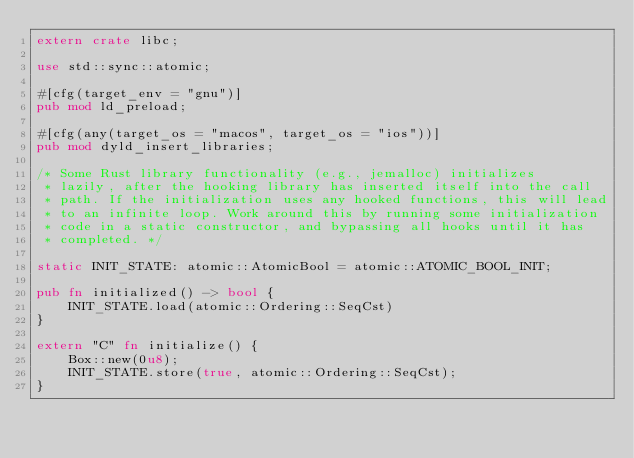Convert code to text. <code><loc_0><loc_0><loc_500><loc_500><_Rust_>extern crate libc;

use std::sync::atomic;

#[cfg(target_env = "gnu")]
pub mod ld_preload;

#[cfg(any(target_os = "macos", target_os = "ios"))]
pub mod dyld_insert_libraries;

/* Some Rust library functionality (e.g., jemalloc) initializes
 * lazily, after the hooking library has inserted itself into the call
 * path. If the initialization uses any hooked functions, this will lead
 * to an infinite loop. Work around this by running some initialization
 * code in a static constructor, and bypassing all hooks until it has
 * completed. */

static INIT_STATE: atomic::AtomicBool = atomic::ATOMIC_BOOL_INIT;

pub fn initialized() -> bool {
    INIT_STATE.load(atomic::Ordering::SeqCst)
}

extern "C" fn initialize() {
    Box::new(0u8);
    INIT_STATE.store(true, atomic::Ordering::SeqCst);
}
</code> 